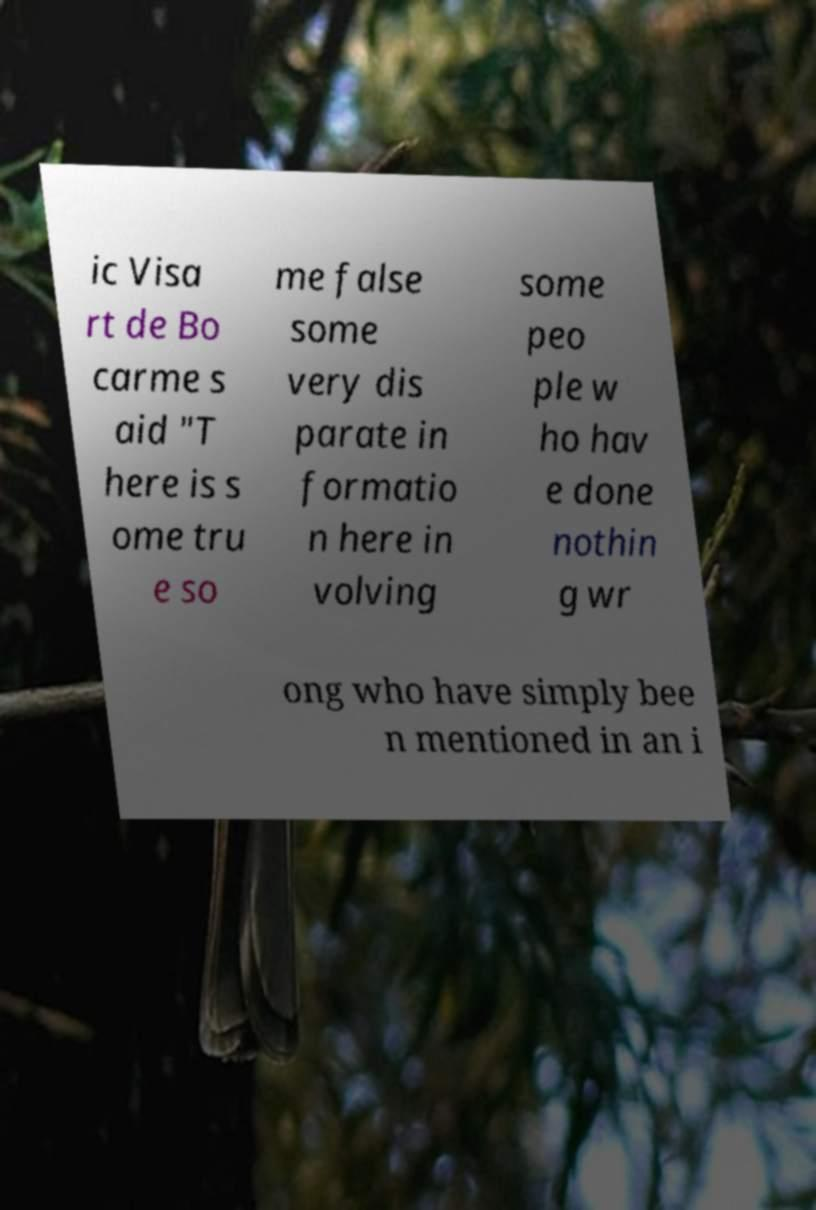There's text embedded in this image that I need extracted. Can you transcribe it verbatim? ic Visa rt de Bo carme s aid "T here is s ome tru e so me false some very dis parate in formatio n here in volving some peo ple w ho hav e done nothin g wr ong who have simply bee n mentioned in an i 